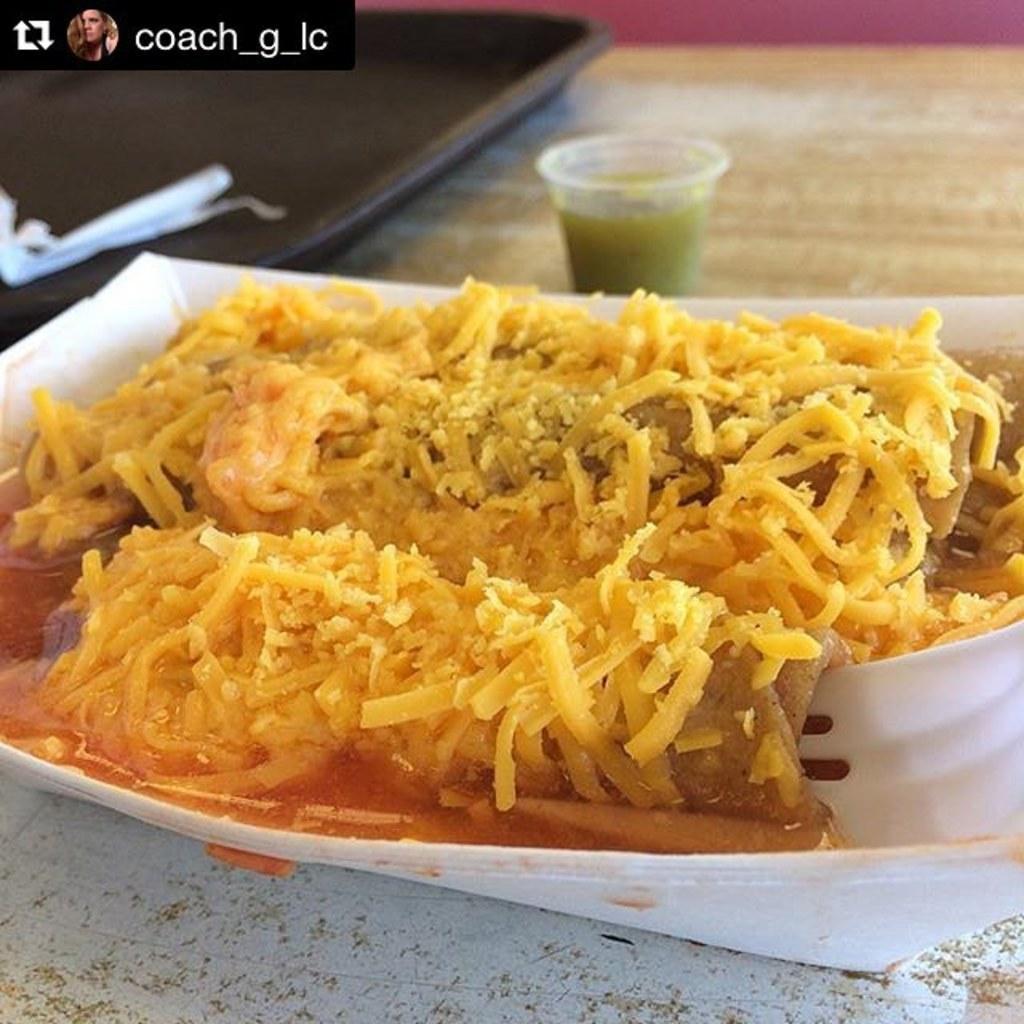Can you describe this image briefly? This image consists of food with his on the plate in the center. 